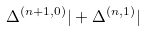Convert formula to latex. <formula><loc_0><loc_0><loc_500><loc_500>\Delta ^ { ( n + 1 , 0 ) } | + \Delta ^ { ( n , 1 ) } |</formula> 